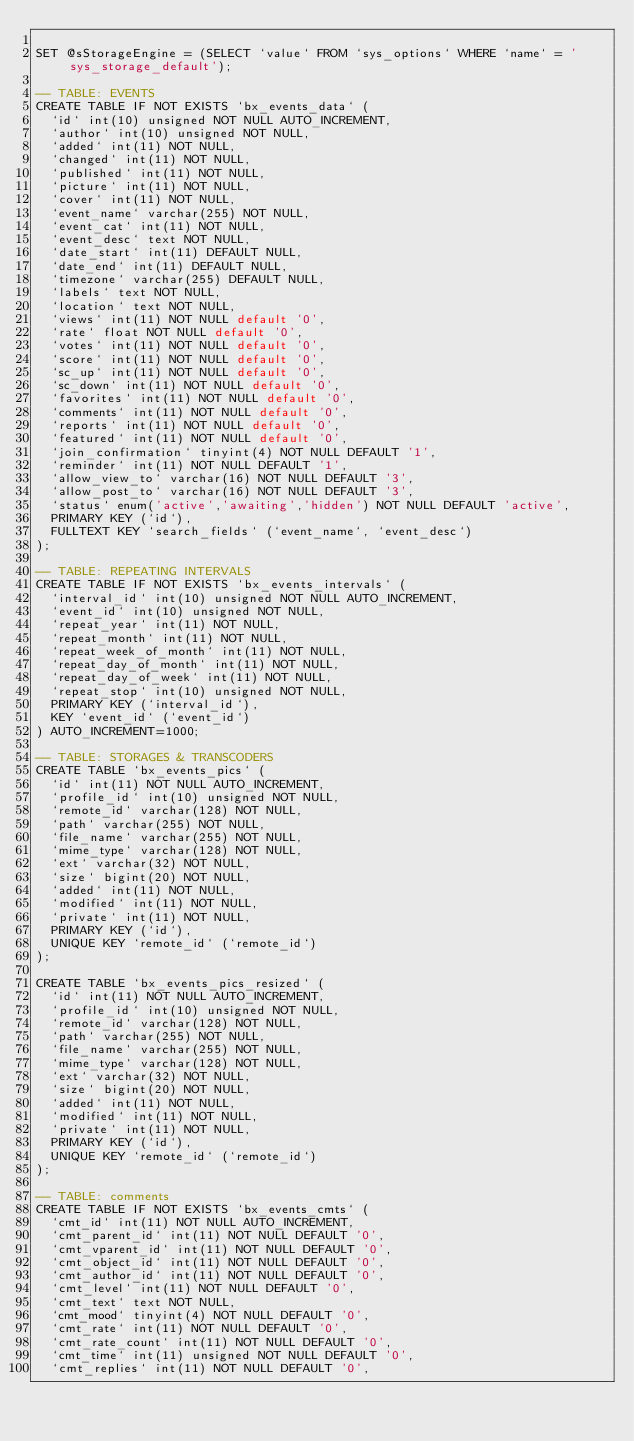Convert code to text. <code><loc_0><loc_0><loc_500><loc_500><_SQL_>
SET @sStorageEngine = (SELECT `value` FROM `sys_options` WHERE `name` = 'sys_storage_default');

-- TABLE: EVENTS
CREATE TABLE IF NOT EXISTS `bx_events_data` (
  `id` int(10) unsigned NOT NULL AUTO_INCREMENT,
  `author` int(10) unsigned NOT NULL,
  `added` int(11) NOT NULL,
  `changed` int(11) NOT NULL,
  `published` int(11) NOT NULL,
  `picture` int(11) NOT NULL,
  `cover` int(11) NOT NULL,
  `event_name` varchar(255) NOT NULL,
  `event_cat` int(11) NOT NULL,
  `event_desc` text NOT NULL,
  `date_start` int(11) DEFAULT NULL,
  `date_end` int(11) DEFAULT NULL,
  `timezone` varchar(255) DEFAULT NULL,
  `labels` text NOT NULL,
  `location` text NOT NULL,
  `views` int(11) NOT NULL default '0',
  `rate` float NOT NULL default '0',
  `votes` int(11) NOT NULL default '0',
  `score` int(11) NOT NULL default '0',
  `sc_up` int(11) NOT NULL default '0',
  `sc_down` int(11) NOT NULL default '0',
  `favorites` int(11) NOT NULL default '0',
  `comments` int(11) NOT NULL default '0',
  `reports` int(11) NOT NULL default '0',
  `featured` int(11) NOT NULL default '0',
  `join_confirmation` tinyint(4) NOT NULL DEFAULT '1',
  `reminder` int(11) NOT NULL DEFAULT '1',
  `allow_view_to` varchar(16) NOT NULL DEFAULT '3',
  `allow_post_to` varchar(16) NOT NULL DEFAULT '3',
  `status` enum('active','awaiting','hidden') NOT NULL DEFAULT 'active',
  PRIMARY KEY (`id`),
  FULLTEXT KEY `search_fields` (`event_name`, `event_desc`)
);

-- TABLE: REPEATING INTERVALS
CREATE TABLE IF NOT EXISTS `bx_events_intervals` (
  `interval_id` int(10) unsigned NOT NULL AUTO_INCREMENT,
  `event_id` int(10) unsigned NOT NULL,
  `repeat_year` int(11) NOT NULL,
  `repeat_month` int(11) NOT NULL,
  `repeat_week_of_month` int(11) NOT NULL,
  `repeat_day_of_month` int(11) NOT NULL,
  `repeat_day_of_week` int(11) NOT NULL,
  `repeat_stop` int(10) unsigned NOT NULL,
  PRIMARY KEY (`interval_id`),
  KEY `event_id` (`event_id`)
) AUTO_INCREMENT=1000;

-- TABLE: STORAGES & TRANSCODERS
CREATE TABLE `bx_events_pics` (
  `id` int(11) NOT NULL AUTO_INCREMENT,
  `profile_id` int(10) unsigned NOT NULL,
  `remote_id` varchar(128) NOT NULL,
  `path` varchar(255) NOT NULL,
  `file_name` varchar(255) NOT NULL,
  `mime_type` varchar(128) NOT NULL,
  `ext` varchar(32) NOT NULL,
  `size` bigint(20) NOT NULL,
  `added` int(11) NOT NULL,
  `modified` int(11) NOT NULL,
  `private` int(11) NOT NULL,
  PRIMARY KEY (`id`),
  UNIQUE KEY `remote_id` (`remote_id`)
);

CREATE TABLE `bx_events_pics_resized` (
  `id` int(11) NOT NULL AUTO_INCREMENT,
  `profile_id` int(10) unsigned NOT NULL,
  `remote_id` varchar(128) NOT NULL,
  `path` varchar(255) NOT NULL,
  `file_name` varchar(255) NOT NULL,
  `mime_type` varchar(128) NOT NULL,
  `ext` varchar(32) NOT NULL,
  `size` bigint(20) NOT NULL,
  `added` int(11) NOT NULL,
  `modified` int(11) NOT NULL,
  `private` int(11) NOT NULL,
  PRIMARY KEY (`id`),
  UNIQUE KEY `remote_id` (`remote_id`)
);

-- TABLE: comments
CREATE TABLE IF NOT EXISTS `bx_events_cmts` (
  `cmt_id` int(11) NOT NULL AUTO_INCREMENT,
  `cmt_parent_id` int(11) NOT NULL DEFAULT '0',
  `cmt_vparent_id` int(11) NOT NULL DEFAULT '0',
  `cmt_object_id` int(11) NOT NULL DEFAULT '0',
  `cmt_author_id` int(11) NOT NULL DEFAULT '0',
  `cmt_level` int(11) NOT NULL DEFAULT '0',
  `cmt_text` text NOT NULL,
  `cmt_mood` tinyint(4) NOT NULL DEFAULT '0',
  `cmt_rate` int(11) NOT NULL DEFAULT '0',
  `cmt_rate_count` int(11) NOT NULL DEFAULT '0',
  `cmt_time` int(11) unsigned NOT NULL DEFAULT '0',
  `cmt_replies` int(11) NOT NULL DEFAULT '0',</code> 